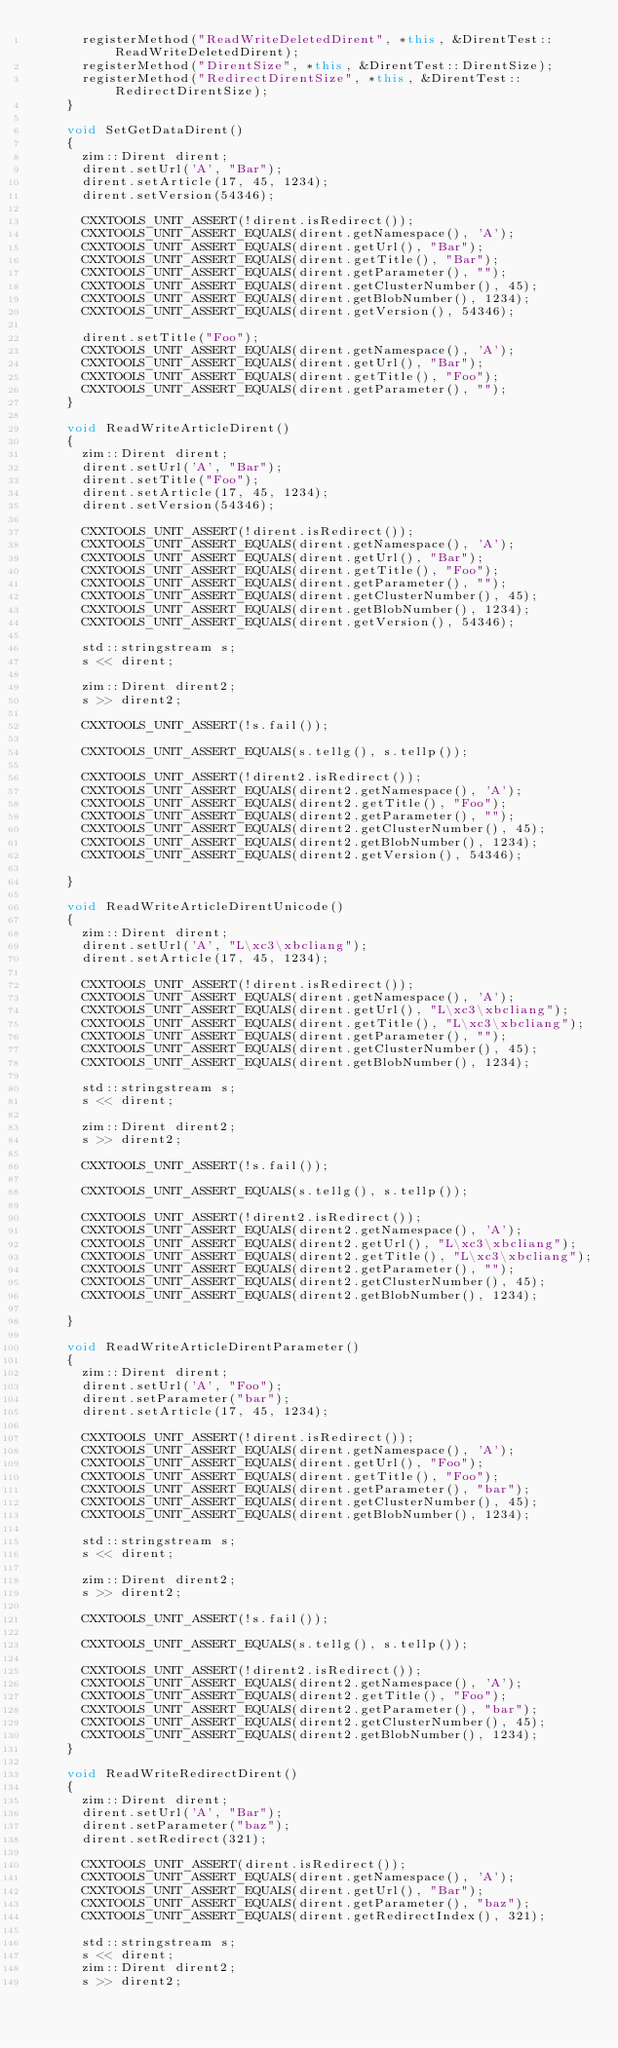Convert code to text. <code><loc_0><loc_0><loc_500><loc_500><_C++_>      registerMethod("ReadWriteDeletedDirent", *this, &DirentTest::ReadWriteDeletedDirent);
      registerMethod("DirentSize", *this, &DirentTest::DirentSize);
      registerMethod("RedirectDirentSize", *this, &DirentTest::RedirectDirentSize);
    }

    void SetGetDataDirent()
    {
      zim::Dirent dirent;
      dirent.setUrl('A', "Bar");
      dirent.setArticle(17, 45, 1234);
      dirent.setVersion(54346);

      CXXTOOLS_UNIT_ASSERT(!dirent.isRedirect());
      CXXTOOLS_UNIT_ASSERT_EQUALS(dirent.getNamespace(), 'A');
      CXXTOOLS_UNIT_ASSERT_EQUALS(dirent.getUrl(), "Bar");
      CXXTOOLS_UNIT_ASSERT_EQUALS(dirent.getTitle(), "Bar");
      CXXTOOLS_UNIT_ASSERT_EQUALS(dirent.getParameter(), "");
      CXXTOOLS_UNIT_ASSERT_EQUALS(dirent.getClusterNumber(), 45);
      CXXTOOLS_UNIT_ASSERT_EQUALS(dirent.getBlobNumber(), 1234);
      CXXTOOLS_UNIT_ASSERT_EQUALS(dirent.getVersion(), 54346);

      dirent.setTitle("Foo");
      CXXTOOLS_UNIT_ASSERT_EQUALS(dirent.getNamespace(), 'A');
      CXXTOOLS_UNIT_ASSERT_EQUALS(dirent.getUrl(), "Bar");
      CXXTOOLS_UNIT_ASSERT_EQUALS(dirent.getTitle(), "Foo");
      CXXTOOLS_UNIT_ASSERT_EQUALS(dirent.getParameter(), "");
    }

    void ReadWriteArticleDirent()
    {
      zim::Dirent dirent;
      dirent.setUrl('A', "Bar");
      dirent.setTitle("Foo");
      dirent.setArticle(17, 45, 1234);
      dirent.setVersion(54346);

      CXXTOOLS_UNIT_ASSERT(!dirent.isRedirect());
      CXXTOOLS_UNIT_ASSERT_EQUALS(dirent.getNamespace(), 'A');
      CXXTOOLS_UNIT_ASSERT_EQUALS(dirent.getUrl(), "Bar");
      CXXTOOLS_UNIT_ASSERT_EQUALS(dirent.getTitle(), "Foo");
      CXXTOOLS_UNIT_ASSERT_EQUALS(dirent.getParameter(), "");
      CXXTOOLS_UNIT_ASSERT_EQUALS(dirent.getClusterNumber(), 45);
      CXXTOOLS_UNIT_ASSERT_EQUALS(dirent.getBlobNumber(), 1234);
      CXXTOOLS_UNIT_ASSERT_EQUALS(dirent.getVersion(), 54346);

      std::stringstream s;
      s << dirent;

      zim::Dirent dirent2;
      s >> dirent2;

      CXXTOOLS_UNIT_ASSERT(!s.fail());

      CXXTOOLS_UNIT_ASSERT_EQUALS(s.tellg(), s.tellp());

      CXXTOOLS_UNIT_ASSERT(!dirent2.isRedirect());
      CXXTOOLS_UNIT_ASSERT_EQUALS(dirent2.getNamespace(), 'A');
      CXXTOOLS_UNIT_ASSERT_EQUALS(dirent2.getTitle(), "Foo");
      CXXTOOLS_UNIT_ASSERT_EQUALS(dirent2.getParameter(), "");
      CXXTOOLS_UNIT_ASSERT_EQUALS(dirent2.getClusterNumber(), 45);
      CXXTOOLS_UNIT_ASSERT_EQUALS(dirent2.getBlobNumber(), 1234);
      CXXTOOLS_UNIT_ASSERT_EQUALS(dirent2.getVersion(), 54346);

    }

    void ReadWriteArticleDirentUnicode()
    {
      zim::Dirent dirent;
      dirent.setUrl('A', "L\xc3\xbcliang");
      dirent.setArticle(17, 45, 1234);

      CXXTOOLS_UNIT_ASSERT(!dirent.isRedirect());
      CXXTOOLS_UNIT_ASSERT_EQUALS(dirent.getNamespace(), 'A');
      CXXTOOLS_UNIT_ASSERT_EQUALS(dirent.getUrl(), "L\xc3\xbcliang");
      CXXTOOLS_UNIT_ASSERT_EQUALS(dirent.getTitle(), "L\xc3\xbcliang");
      CXXTOOLS_UNIT_ASSERT_EQUALS(dirent.getParameter(), "");
      CXXTOOLS_UNIT_ASSERT_EQUALS(dirent.getClusterNumber(), 45);
      CXXTOOLS_UNIT_ASSERT_EQUALS(dirent.getBlobNumber(), 1234);

      std::stringstream s;
      s << dirent;

      zim::Dirent dirent2;
      s >> dirent2;

      CXXTOOLS_UNIT_ASSERT(!s.fail());

      CXXTOOLS_UNIT_ASSERT_EQUALS(s.tellg(), s.tellp());

      CXXTOOLS_UNIT_ASSERT(!dirent2.isRedirect());
      CXXTOOLS_UNIT_ASSERT_EQUALS(dirent2.getNamespace(), 'A');
      CXXTOOLS_UNIT_ASSERT_EQUALS(dirent2.getUrl(), "L\xc3\xbcliang");
      CXXTOOLS_UNIT_ASSERT_EQUALS(dirent2.getTitle(), "L\xc3\xbcliang");
      CXXTOOLS_UNIT_ASSERT_EQUALS(dirent2.getParameter(), "");
      CXXTOOLS_UNIT_ASSERT_EQUALS(dirent2.getClusterNumber(), 45);
      CXXTOOLS_UNIT_ASSERT_EQUALS(dirent2.getBlobNumber(), 1234);

    }

    void ReadWriteArticleDirentParameter()
    {
      zim::Dirent dirent;
      dirent.setUrl('A', "Foo");
      dirent.setParameter("bar");
      dirent.setArticle(17, 45, 1234);

      CXXTOOLS_UNIT_ASSERT(!dirent.isRedirect());
      CXXTOOLS_UNIT_ASSERT_EQUALS(dirent.getNamespace(), 'A');
      CXXTOOLS_UNIT_ASSERT_EQUALS(dirent.getUrl(), "Foo");
      CXXTOOLS_UNIT_ASSERT_EQUALS(dirent.getTitle(), "Foo");
      CXXTOOLS_UNIT_ASSERT_EQUALS(dirent.getParameter(), "bar");
      CXXTOOLS_UNIT_ASSERT_EQUALS(dirent.getClusterNumber(), 45);
      CXXTOOLS_UNIT_ASSERT_EQUALS(dirent.getBlobNumber(), 1234);

      std::stringstream s;
      s << dirent;

      zim::Dirent dirent2;
      s >> dirent2;

      CXXTOOLS_UNIT_ASSERT(!s.fail());

      CXXTOOLS_UNIT_ASSERT_EQUALS(s.tellg(), s.tellp());

      CXXTOOLS_UNIT_ASSERT(!dirent2.isRedirect());
      CXXTOOLS_UNIT_ASSERT_EQUALS(dirent2.getNamespace(), 'A');
      CXXTOOLS_UNIT_ASSERT_EQUALS(dirent2.getTitle(), "Foo");
      CXXTOOLS_UNIT_ASSERT_EQUALS(dirent2.getParameter(), "bar");
      CXXTOOLS_UNIT_ASSERT_EQUALS(dirent2.getClusterNumber(), 45);
      CXXTOOLS_UNIT_ASSERT_EQUALS(dirent2.getBlobNumber(), 1234);
    }

    void ReadWriteRedirectDirent()
    {
      zim::Dirent dirent;
      dirent.setUrl('A', "Bar");
      dirent.setParameter("baz");
      dirent.setRedirect(321);

      CXXTOOLS_UNIT_ASSERT(dirent.isRedirect());
      CXXTOOLS_UNIT_ASSERT_EQUALS(dirent.getNamespace(), 'A');
      CXXTOOLS_UNIT_ASSERT_EQUALS(dirent.getUrl(), "Bar");
      CXXTOOLS_UNIT_ASSERT_EQUALS(dirent.getParameter(), "baz");
      CXXTOOLS_UNIT_ASSERT_EQUALS(dirent.getRedirectIndex(), 321);

      std::stringstream s;
      s << dirent;
      zim::Dirent dirent2;
      s >> dirent2;
</code> 